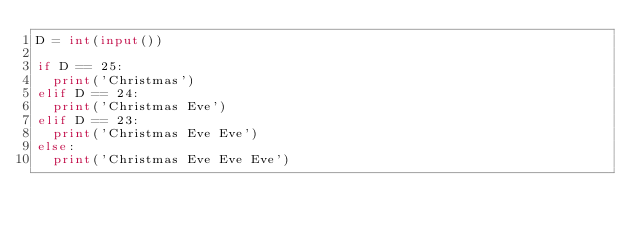Convert code to text. <code><loc_0><loc_0><loc_500><loc_500><_Python_>D = int(input())

if D == 25:
  print('Christmas')
elif D == 24:
  print('Christmas Eve')
elif D == 23:
  print('Christmas Eve Eve')
else:
  print('Christmas Eve Eve Eve')</code> 